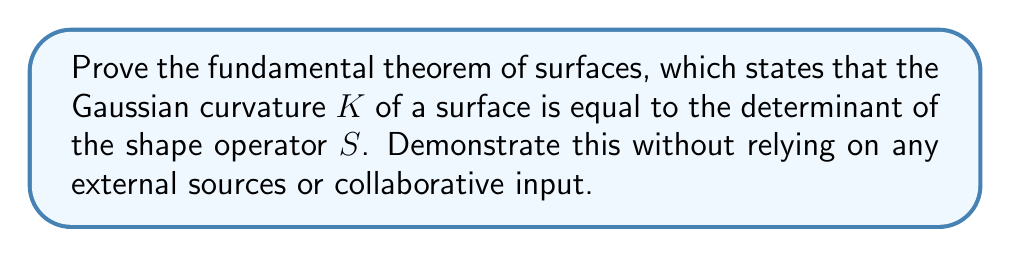Solve this math problem. To prove this theorem independently, we'll follow these steps:

1) First, recall that the Gaussian curvature $K$ is defined as the product of the principal curvatures:

   $$K = k_1 k_2$$

2) The shape operator $S$ is defined in terms of the second fundamental form $II$ and the first fundamental form $I$:

   $$S = I^{-1} \circ II$$

3) In a principal coordinate system, the first and second fundamental forms are diagonal:

   $$I = \begin{pmatrix} E & 0 \\ 0 & G \end{pmatrix}, \quad II = \begin{pmatrix} k_1E & 0 \\ 0 & k_2G \end{pmatrix}$$

4) Therefore, in this coordinate system, the shape operator is:

   $$S = \begin{pmatrix} E^{-1} & 0 \\ 0 & G^{-1} \end{pmatrix} \begin{pmatrix} k_1E & 0 \\ 0 & k_2G \end{pmatrix} = \begin{pmatrix} k_1 & 0 \\ 0 & k_2 \end{pmatrix}$$

5) The determinant of $S$ is thus:

   $$\det(S) = k_1 k_2$$

6) Comparing this with the definition of Gaussian curvature from step 1, we see that:

   $$K = \det(S)$$

This completes the proof of the fundamental theorem of surfaces.
Answer: $K = \det(S)$ 